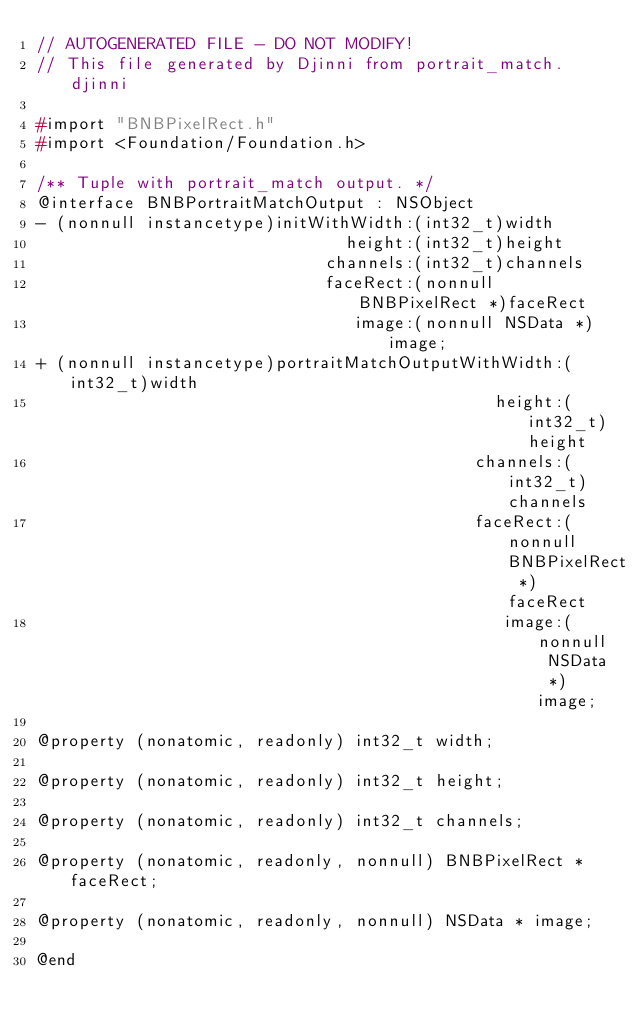<code> <loc_0><loc_0><loc_500><loc_500><_C_>// AUTOGENERATED FILE - DO NOT MODIFY!
// This file generated by Djinni from portrait_match.djinni

#import "BNBPixelRect.h"
#import <Foundation/Foundation.h>

/** Tuple with portrait_match output. */
@interface BNBPortraitMatchOutput : NSObject
- (nonnull instancetype)initWithWidth:(int32_t)width
                               height:(int32_t)height
                             channels:(int32_t)channels
                             faceRect:(nonnull BNBPixelRect *)faceRect
                                image:(nonnull NSData *)image;
+ (nonnull instancetype)portraitMatchOutputWithWidth:(int32_t)width
                                              height:(int32_t)height
                                            channels:(int32_t)channels
                                            faceRect:(nonnull BNBPixelRect *)faceRect
                                               image:(nonnull NSData *)image;

@property (nonatomic, readonly) int32_t width;

@property (nonatomic, readonly) int32_t height;

@property (nonatomic, readonly) int32_t channels;

@property (nonatomic, readonly, nonnull) BNBPixelRect * faceRect;

@property (nonatomic, readonly, nonnull) NSData * image;

@end
</code> 